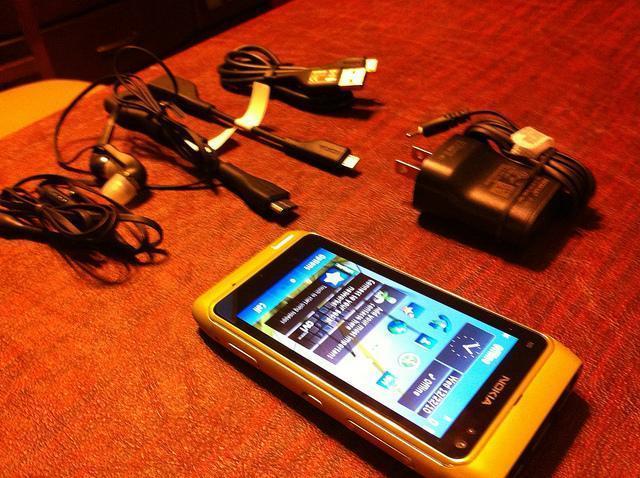How many cell phones are in the photo?
Give a very brief answer. 1. How many horses are adults in this image?
Give a very brief answer. 0. 